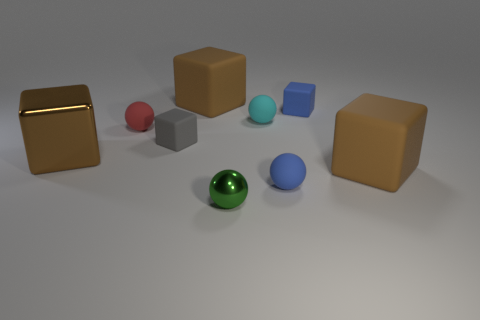Are the gray block and the big cube to the left of the tiny gray object made of the same material?
Your answer should be very brief. No. The small matte ball that is on the right side of the green ball and behind the small gray thing is what color?
Provide a succinct answer. Cyan. How many cubes are either tiny matte objects or cyan things?
Keep it short and to the point. 2. There is a small gray object; does it have the same shape as the big matte object that is to the right of the small metallic object?
Make the answer very short. Yes. How big is the rubber cube that is in front of the small cyan ball and left of the small green metal ball?
Your answer should be compact. Small. The tiny shiny object has what shape?
Make the answer very short. Sphere. Are there any tiny matte cubes that are right of the small blue thing that is in front of the small blue cube?
Keep it short and to the point. Yes. There is a big brown thing that is behind the red rubber sphere; what number of small red objects are right of it?
Provide a short and direct response. 0. What material is the green object that is the same size as the gray matte block?
Give a very brief answer. Metal. There is a big brown rubber object right of the shiny sphere; is its shape the same as the small gray object?
Provide a succinct answer. Yes. 